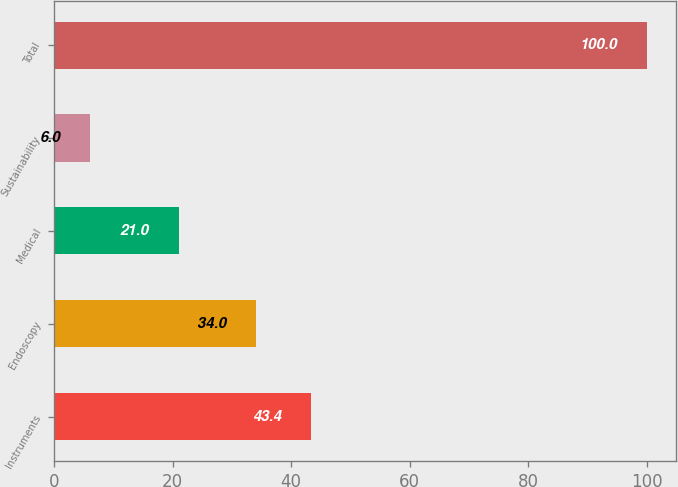Convert chart. <chart><loc_0><loc_0><loc_500><loc_500><bar_chart><fcel>Instruments<fcel>Endoscopy<fcel>Medical<fcel>Sustainability<fcel>Total<nl><fcel>43.4<fcel>34<fcel>21<fcel>6<fcel>100<nl></chart> 